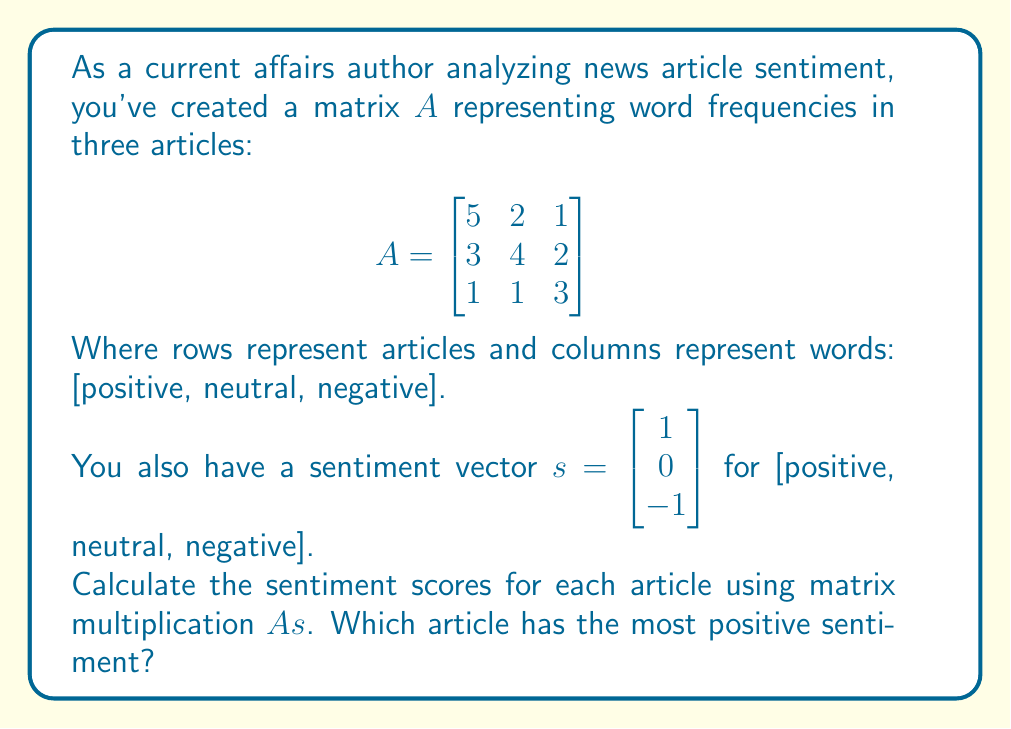Give your solution to this math problem. To solve this problem, we need to perform matrix multiplication between matrix $A$ and vector $s$. The resulting vector will give us the sentiment scores for each article.

Step 1: Set up the matrix multiplication
$$As = \begin{bmatrix}
5 & 2 & 1 \\
3 & 4 & 2 \\
1 & 1 & 3
\end{bmatrix} \begin{bmatrix}
1 \\
0 \\
-1
\end{bmatrix}$$

Step 2: Multiply each row of $A$ by vector $s$

For the first article:
$5(1) + 2(0) + 1(-1) = 5 - 1 = 4$

For the second article:
$3(1) + 4(0) + 2(-1) = 3 - 2 = 1$

For the third article:
$1(1) + 1(0) + 3(-1) = 1 - 3 = -2$

Step 3: Write the result as a vector
$$As = \begin{bmatrix}
4 \\
1 \\
-2
\end{bmatrix}$$

Step 4: Identify the article with the highest sentiment score

The first article has the highest score of 4, indicating the most positive sentiment.
Answer: The first article (score: 4) 